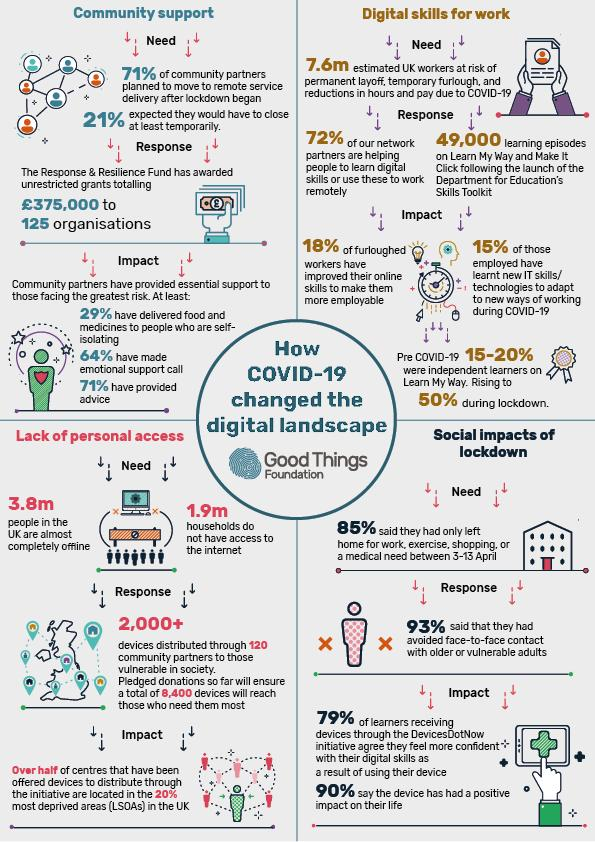Give some essential details in this illustration. The Response & Resilience Fund in the UK awarded a total of 125 unrestricted grants to organisations to help them overcome the COVID-19 crisis. During the lockdown, approximately 50% of independent learners used the Learn My Way website for self-guided learning. During the lockdown period, 3.8 million people in the UK were completely offline. During the lockdown period in the UK, approximately 1.9 million households were found to lack access to the internet, as stated in a recent estimate. The Response & Resilience Fund in the UK has made a total of 375,000 pounds available in grants to address the impact of the COVID-19 crisis. 